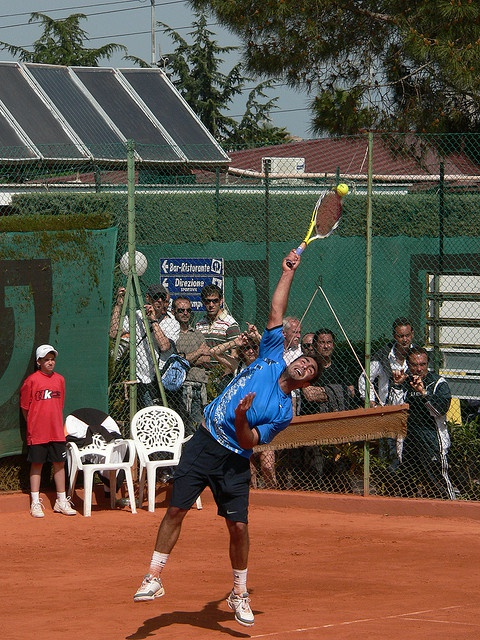Describe the objects in this image and their specific colors. I can see people in darkgray, black, brown, and maroon tones, people in darkgray, black, gray, and maroon tones, people in darkgray, black, brown, and maroon tones, chair in darkgray, white, black, and maroon tones, and people in darkgray, black, gray, and lightgray tones in this image. 